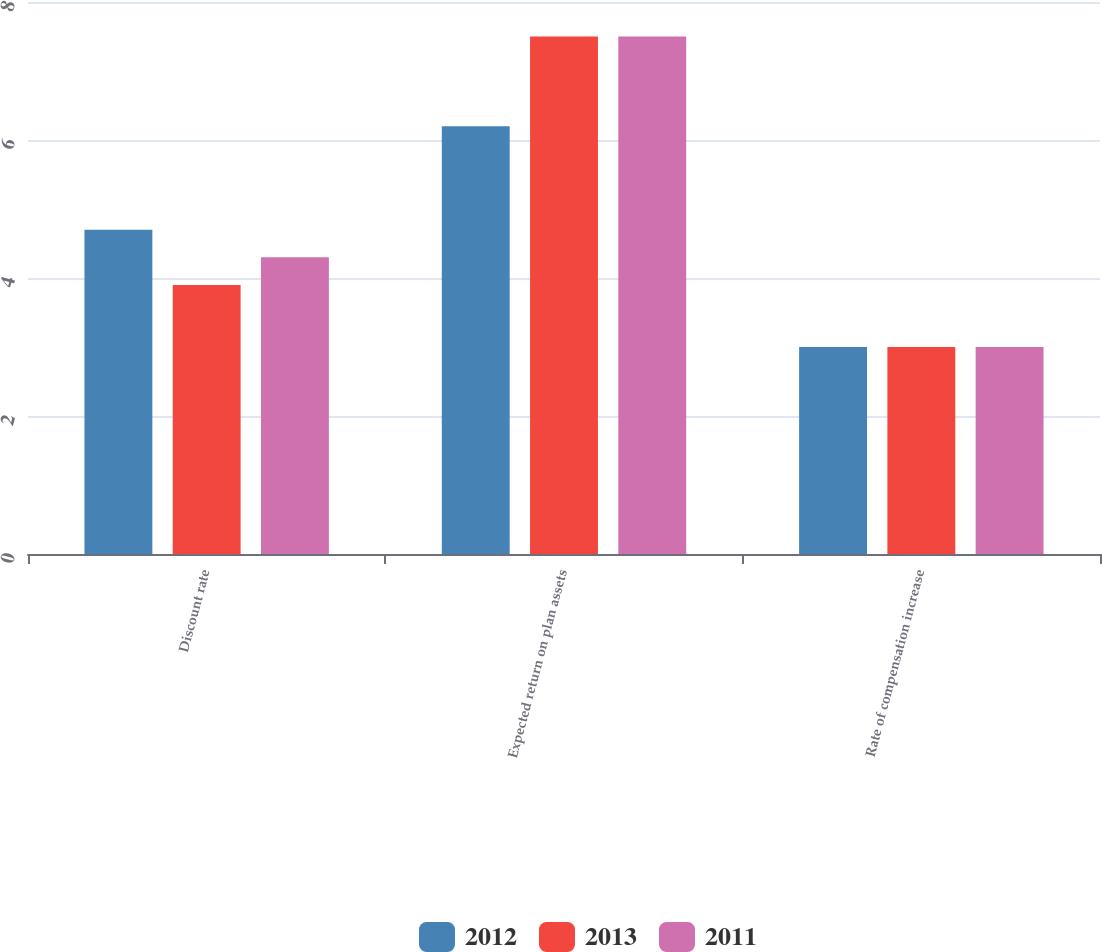<chart> <loc_0><loc_0><loc_500><loc_500><stacked_bar_chart><ecel><fcel>Discount rate<fcel>Expected return on plan assets<fcel>Rate of compensation increase<nl><fcel>2012<fcel>4.7<fcel>6.2<fcel>3<nl><fcel>2013<fcel>3.9<fcel>7.5<fcel>3<nl><fcel>2011<fcel>4.3<fcel>7.5<fcel>3<nl></chart> 